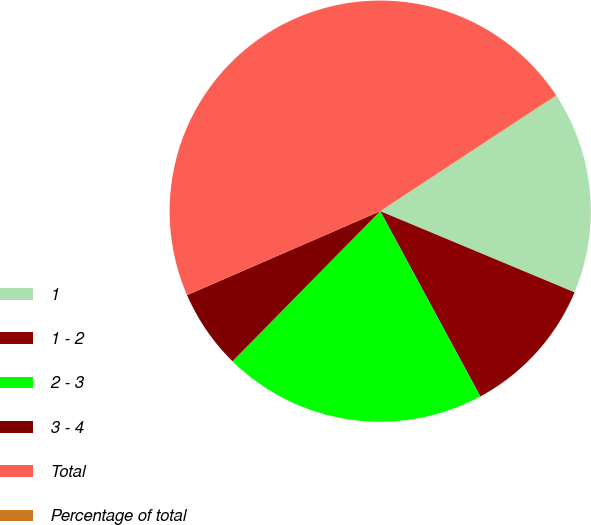<chart> <loc_0><loc_0><loc_500><loc_500><pie_chart><fcel>1<fcel>1 - 2<fcel>2 - 3<fcel>3 - 4<fcel>Total<fcel>Percentage of total<nl><fcel>15.54%<fcel>10.82%<fcel>20.26%<fcel>6.1%<fcel>47.24%<fcel>0.05%<nl></chart> 